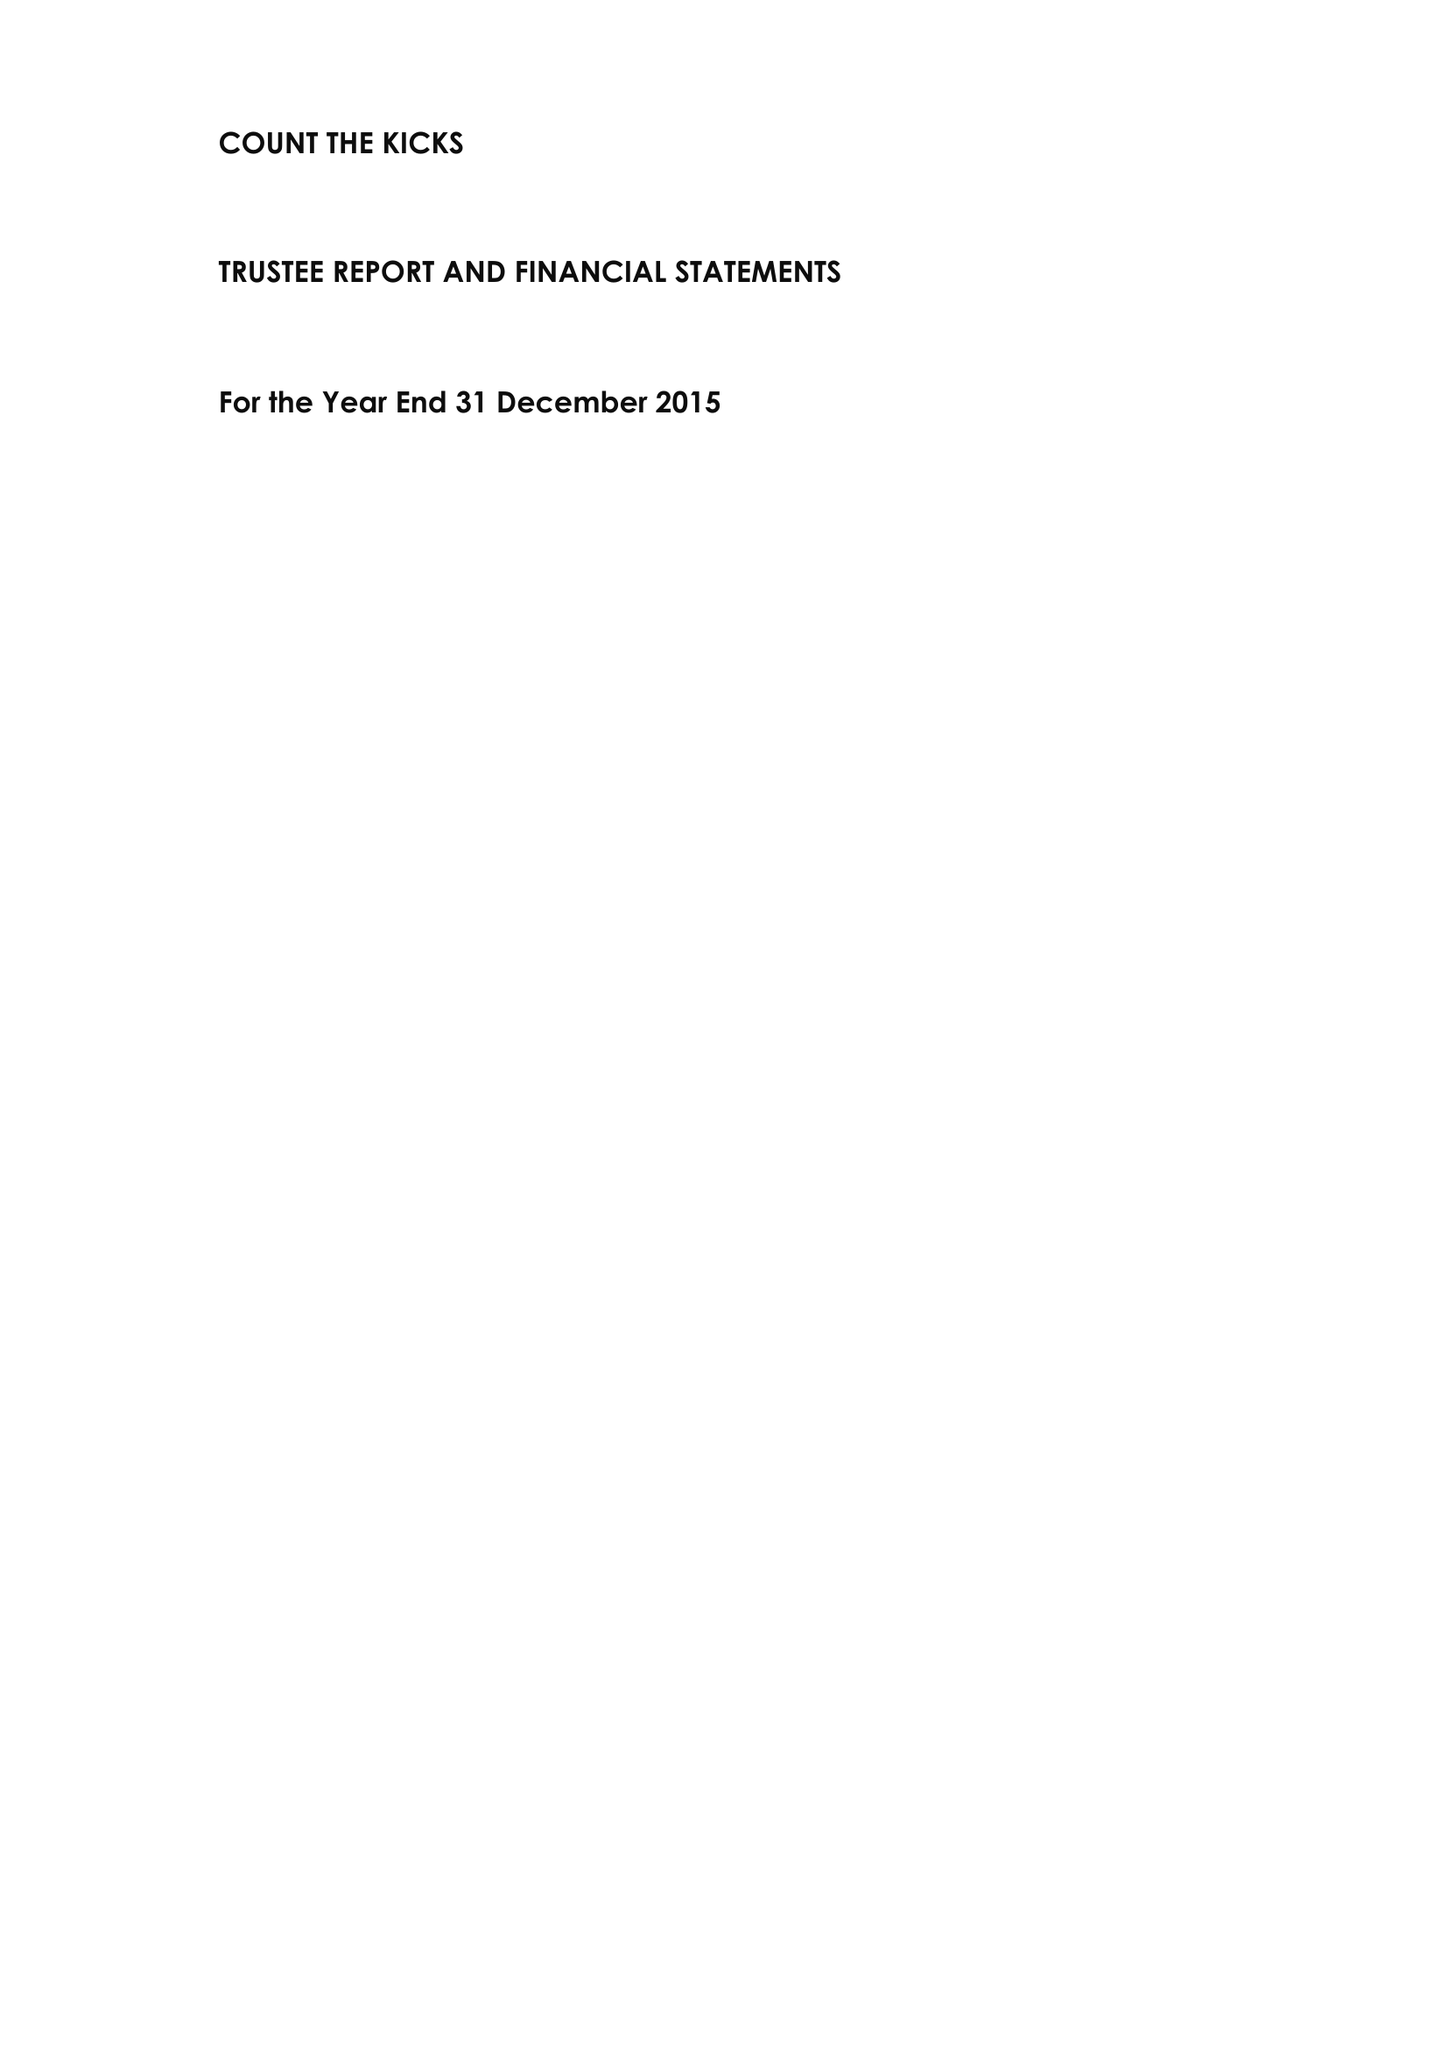What is the value for the spending_annually_in_british_pounds?
Answer the question using a single word or phrase. 228451.00 